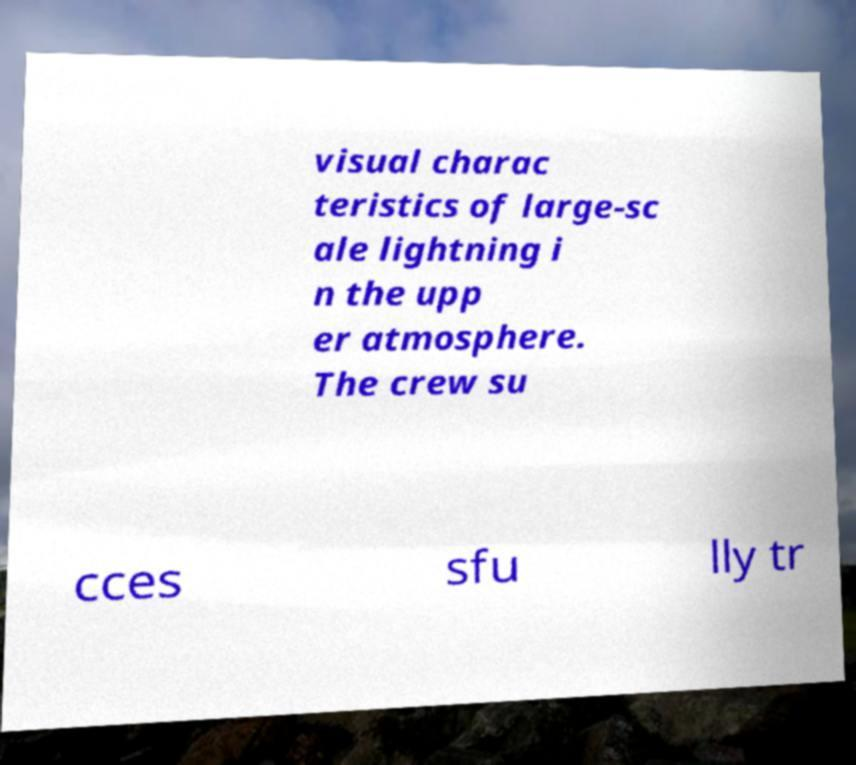Could you extract and type out the text from this image? visual charac teristics of large-sc ale lightning i n the upp er atmosphere. The crew su cces sfu lly tr 